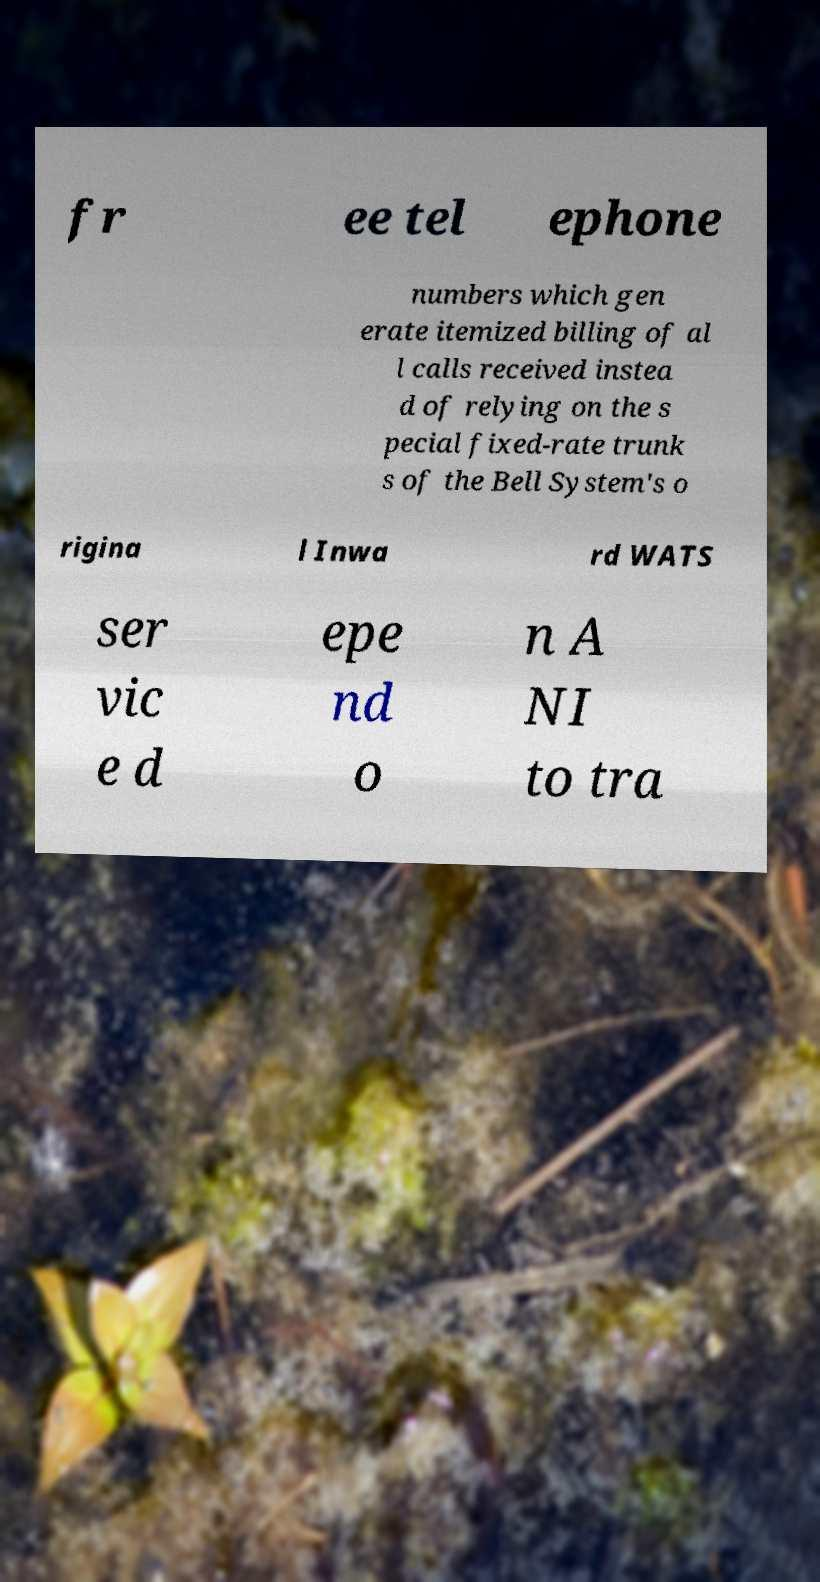What messages or text are displayed in this image? I need them in a readable, typed format. fr ee tel ephone numbers which gen erate itemized billing of al l calls received instea d of relying on the s pecial fixed-rate trunk s of the Bell System's o rigina l Inwa rd WATS ser vic e d epe nd o n A NI to tra 